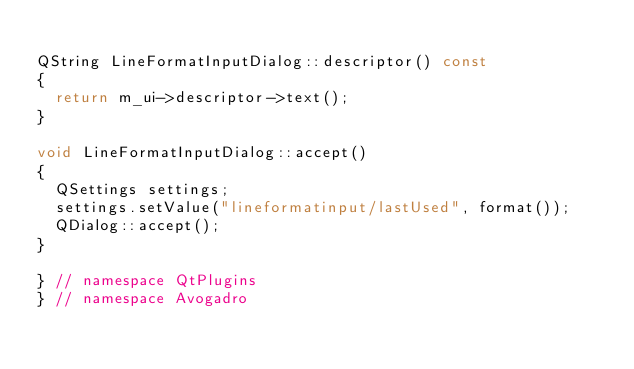Convert code to text. <code><loc_0><loc_0><loc_500><loc_500><_C++_>
QString LineFormatInputDialog::descriptor() const
{
  return m_ui->descriptor->text();
}

void LineFormatInputDialog::accept()
{
  QSettings settings;
  settings.setValue("lineformatinput/lastUsed", format());
  QDialog::accept();
}

} // namespace QtPlugins
} // namespace Avogadro
</code> 